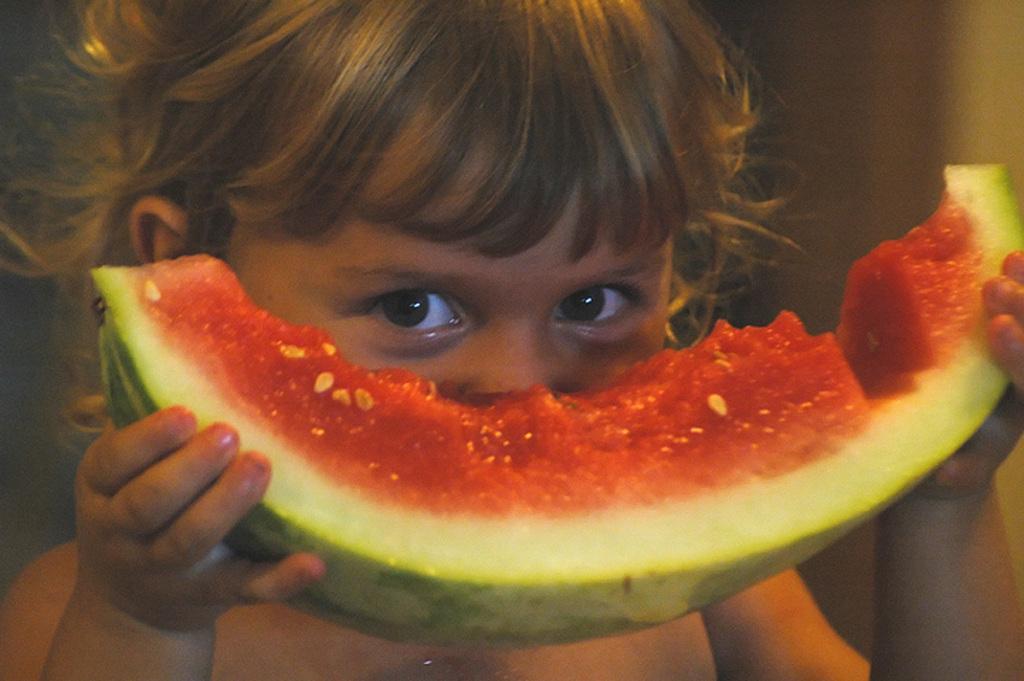Can you describe this image briefly? The girl in front of the picture is holding a slice of watermelon in her hands. She is looking at the camera. In the background, it is blurred. 